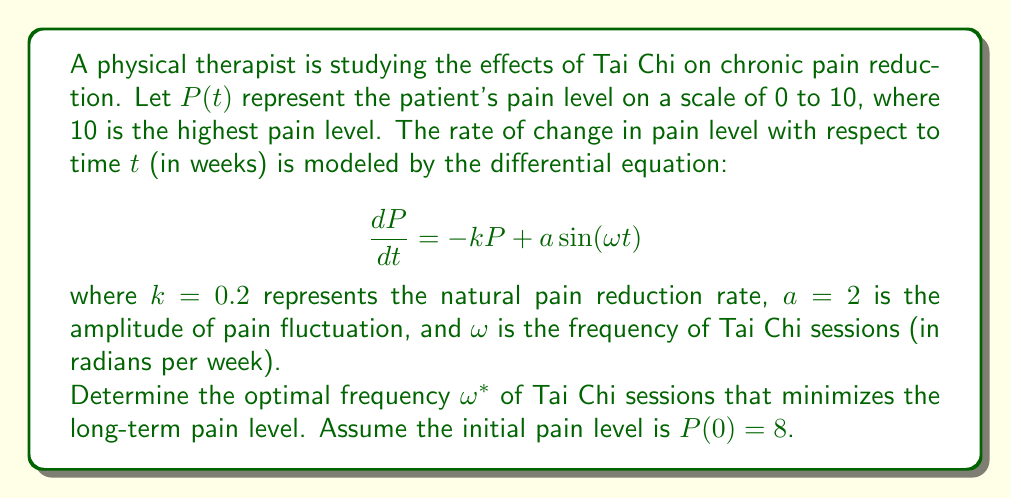What is the answer to this math problem? To solve this problem, we need to follow these steps:

1) First, we need to find the general solution to the differential equation. The general solution is the sum of the homogeneous solution and a particular solution.

2) The homogeneous solution is:
   $$P_h(t) = Ce^{-kt} = Ce^{-0.2t}$$

3) For the particular solution, we assume a form:
   $$P_p(t) = A\cos(\omega t) + B\sin(\omega t)$$

4) Substituting this into the original equation:
   $$-A\omega\sin(\omega t) + B\omega\cos(\omega t) = -k(A\cos(\omega t) + B\sin(\omega t)) + a\sin(\omega t)$$

5) Equating coefficients:
   $$-A\omega = -kB$$
   $$B\omega = -kA + a$$

6) Solving these equations:
   $$A = \frac{-ka}{\omega^2 + k^2}, B = \frac{\omega a}{\omega^2 + k^2}$$

7) Therefore, the general solution is:
   $$P(t) = Ce^{-kt} + \frac{a}{\sqrt{\omega^2 + k^2}}\sin(\omega t - \phi)$$
   where $\phi = \tan^{-1}(\frac{k}{\omega})$

8) Using the initial condition $P(0) = 8$:
   $$8 = C + \frac{a}{\sqrt{\omega^2 + k^2}}\sin(-\phi)$$

9) In the long term, as $t \to \infty$, the $e^{-kt}$ term approaches zero, so the long-term behavior is governed by:
   $$P_{\infty}(t) = \frac{a}{\sqrt{\omega^2 + k^2}}\sin(\omega t - \phi)$$

10) The amplitude of this oscillation is $\frac{a}{\sqrt{\omega^2 + k^2}}$. To minimize the long-term pain level, we need to minimize this amplitude.

11) Differentiating with respect to $\omega$ and setting to zero:
    $$\frac{d}{d\omega}\left(\frac{a}{\sqrt{\omega^2 + k^2}}\right) = \frac{-a\omega}{(\omega^2 + k^2)^{3/2}} = 0$$

12) This is satisfied when $\omega = 0$. The second derivative is positive at this point, confirming it's a minimum.

Therefore, the optimal frequency $\omega^*$ is 0 radians per week.
Answer: The optimal frequency of Tai Chi sessions to minimize long-term pain level is $\omega^* = 0$ radians per week. 